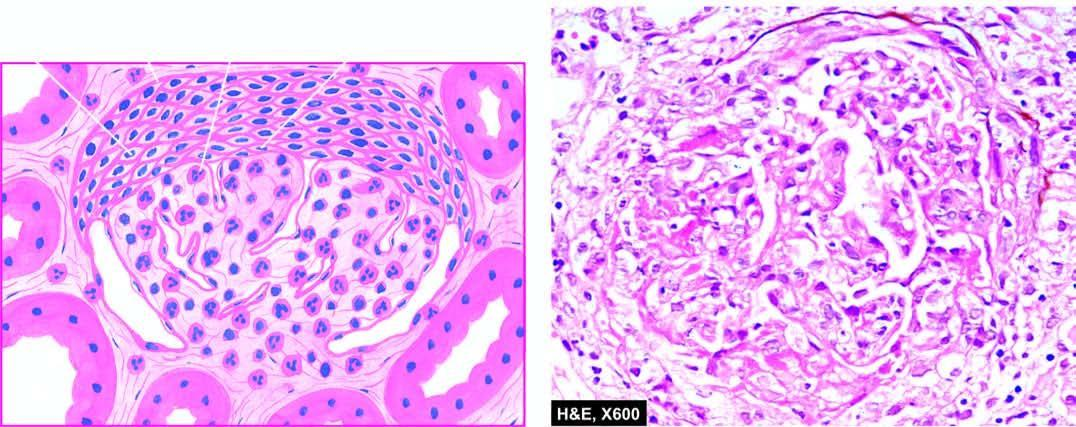re 'triple response ' crescents in bowman 's space forming adhesions between the glomerular tuft and bowman 's capsule?
Answer the question using a single word or phrase. No 